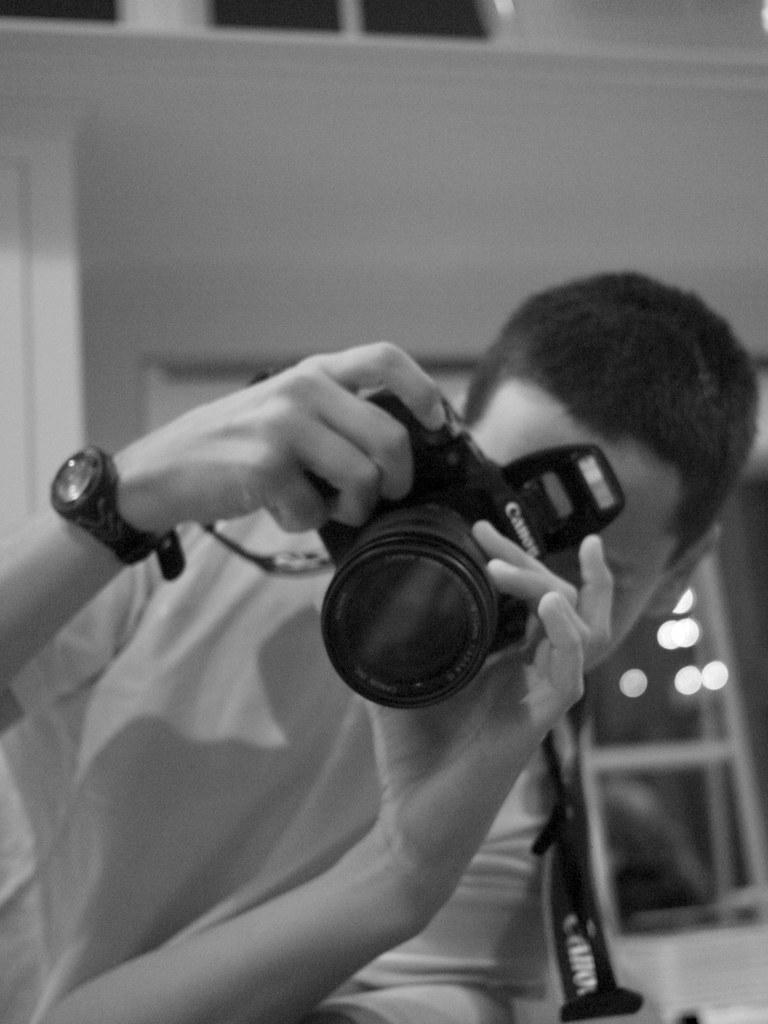What is the color scheme of the image? The image is black and white. What is the man in the image doing? The man is laying down in the image. What object is the man holding in his hands? The man is holding a Canon camera in his hands. What accessory is the man wearing on his wrist? The man is wearing a wristwatch on his hand. What route is the man planning to take in the image? There is no indication of a route or any travel plans in the image; it simply shows a man laying down with a camera and a wristwatch. 